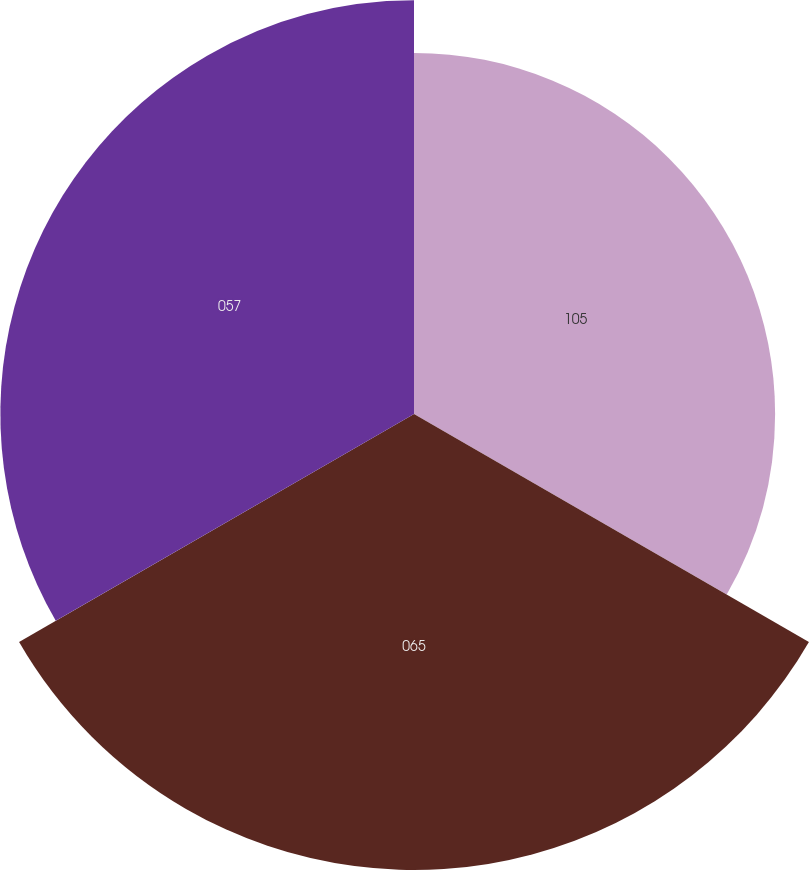Convert chart to OTSL. <chart><loc_0><loc_0><loc_500><loc_500><pie_chart><fcel>105<fcel>065<fcel>057<nl><fcel>29.34%<fcel>37.05%<fcel>33.61%<nl></chart> 